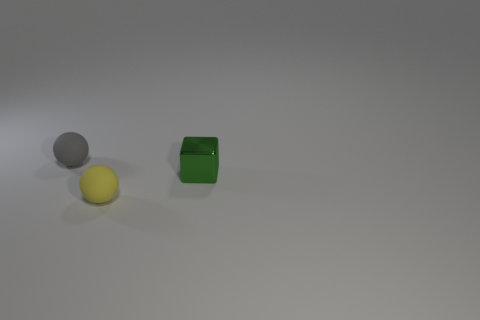What number of things are tiny matte spheres that are in front of the tiny gray rubber thing or small balls that are in front of the green shiny block?
Ensure brevity in your answer.  1. Is the number of tiny brown rubber things greater than the number of small things?
Provide a succinct answer. No. There is a small sphere in front of the tiny gray rubber ball; what color is it?
Offer a very short reply. Yellow. Do the gray matte thing and the metal thing have the same shape?
Ensure brevity in your answer.  No. There is a small object that is left of the shiny thing and right of the small gray thing; what color is it?
Your answer should be very brief. Yellow. Does the object on the left side of the yellow thing have the same size as the thing on the right side of the yellow matte ball?
Your response must be concise. Yes. What number of things are tiny objects that are behind the tiny shiny cube or small yellow matte spheres?
Give a very brief answer. 2. What material is the yellow object?
Your answer should be compact. Rubber. Is the size of the yellow rubber object the same as the gray rubber sphere?
Provide a succinct answer. Yes. How many spheres are tiny matte things or shiny things?
Your answer should be very brief. 2. 